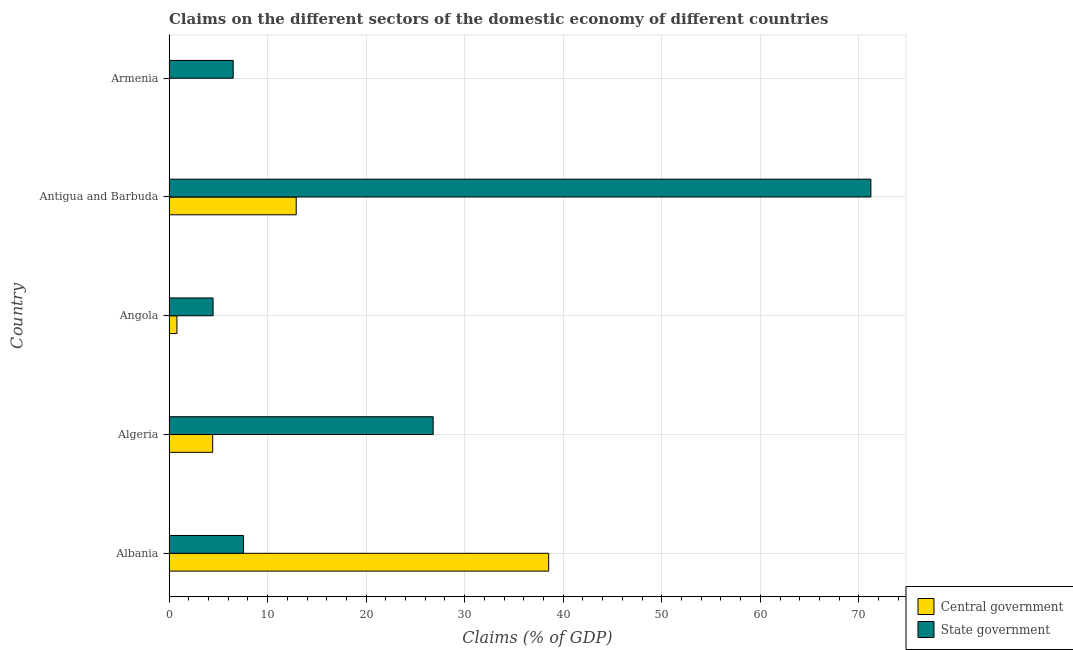Are the number of bars on each tick of the Y-axis equal?
Your response must be concise. No. What is the label of the 5th group of bars from the top?
Keep it short and to the point. Albania. What is the claims on state government in Angola?
Offer a terse response. 4.47. Across all countries, what is the maximum claims on central government?
Give a very brief answer. 38.52. In which country was the claims on state government maximum?
Your answer should be very brief. Antigua and Barbuda. What is the total claims on central government in the graph?
Offer a terse response. 56.66. What is the difference between the claims on state government in Angola and that in Armenia?
Make the answer very short. -2.04. What is the difference between the claims on central government in Antigua and Barbuda and the claims on state government in Algeria?
Your answer should be very brief. -13.9. What is the average claims on state government per country?
Give a very brief answer. 23.31. What is the difference between the claims on central government and claims on state government in Angola?
Keep it short and to the point. -3.67. In how many countries, is the claims on central government greater than 44 %?
Your answer should be very brief. 0. What is the ratio of the claims on central government in Angola to that in Antigua and Barbuda?
Provide a short and direct response. 0.06. Is the difference between the claims on central government in Albania and Antigua and Barbuda greater than the difference between the claims on state government in Albania and Antigua and Barbuda?
Provide a succinct answer. Yes. What is the difference between the highest and the second highest claims on state government?
Keep it short and to the point. 44.41. What is the difference between the highest and the lowest claims on central government?
Give a very brief answer. 38.52. In how many countries, is the claims on state government greater than the average claims on state government taken over all countries?
Make the answer very short. 2. Is the sum of the claims on state government in Albania and Algeria greater than the maximum claims on central government across all countries?
Make the answer very short. No. How many bars are there?
Your response must be concise. 9. What is the difference between two consecutive major ticks on the X-axis?
Your answer should be very brief. 10. Does the graph contain any zero values?
Your answer should be compact. Yes. Where does the legend appear in the graph?
Offer a terse response. Bottom right. How many legend labels are there?
Make the answer very short. 2. How are the legend labels stacked?
Your answer should be compact. Vertical. What is the title of the graph?
Your response must be concise. Claims on the different sectors of the domestic economy of different countries. What is the label or title of the X-axis?
Ensure brevity in your answer.  Claims (% of GDP). What is the label or title of the Y-axis?
Your answer should be very brief. Country. What is the Claims (% of GDP) in Central government in Albania?
Your answer should be compact. 38.52. What is the Claims (% of GDP) of State government in Albania?
Your answer should be very brief. 7.56. What is the Claims (% of GDP) in Central government in Algeria?
Make the answer very short. 4.43. What is the Claims (% of GDP) in State government in Algeria?
Your answer should be very brief. 26.8. What is the Claims (% of GDP) in Central government in Angola?
Your answer should be compact. 0.81. What is the Claims (% of GDP) in State government in Angola?
Your answer should be very brief. 4.47. What is the Claims (% of GDP) of Central government in Antigua and Barbuda?
Offer a terse response. 12.91. What is the Claims (% of GDP) of State government in Antigua and Barbuda?
Your response must be concise. 71.21. What is the Claims (% of GDP) in State government in Armenia?
Offer a very short reply. 6.51. Across all countries, what is the maximum Claims (% of GDP) in Central government?
Ensure brevity in your answer.  38.52. Across all countries, what is the maximum Claims (% of GDP) in State government?
Offer a very short reply. 71.21. Across all countries, what is the minimum Claims (% of GDP) in State government?
Provide a succinct answer. 4.47. What is the total Claims (% of GDP) of Central government in the graph?
Your answer should be compact. 56.66. What is the total Claims (% of GDP) in State government in the graph?
Provide a succinct answer. 116.56. What is the difference between the Claims (% of GDP) of Central government in Albania and that in Algeria?
Offer a terse response. 34.09. What is the difference between the Claims (% of GDP) of State government in Albania and that in Algeria?
Provide a short and direct response. -19.24. What is the difference between the Claims (% of GDP) in Central government in Albania and that in Angola?
Your answer should be compact. 37.71. What is the difference between the Claims (% of GDP) in State government in Albania and that in Angola?
Ensure brevity in your answer.  3.09. What is the difference between the Claims (% of GDP) in Central government in Albania and that in Antigua and Barbuda?
Provide a succinct answer. 25.61. What is the difference between the Claims (% of GDP) of State government in Albania and that in Antigua and Barbuda?
Your answer should be very brief. -63.65. What is the difference between the Claims (% of GDP) of State government in Albania and that in Armenia?
Make the answer very short. 1.05. What is the difference between the Claims (% of GDP) in Central government in Algeria and that in Angola?
Your answer should be very brief. 3.63. What is the difference between the Claims (% of GDP) of State government in Algeria and that in Angola?
Offer a very short reply. 22.33. What is the difference between the Claims (% of GDP) in Central government in Algeria and that in Antigua and Barbuda?
Ensure brevity in your answer.  -8.47. What is the difference between the Claims (% of GDP) of State government in Algeria and that in Antigua and Barbuda?
Offer a very short reply. -44.41. What is the difference between the Claims (% of GDP) in State government in Algeria and that in Armenia?
Provide a succinct answer. 20.29. What is the difference between the Claims (% of GDP) of Central government in Angola and that in Antigua and Barbuda?
Make the answer very short. -12.1. What is the difference between the Claims (% of GDP) in State government in Angola and that in Antigua and Barbuda?
Keep it short and to the point. -66.74. What is the difference between the Claims (% of GDP) of State government in Angola and that in Armenia?
Give a very brief answer. -2.04. What is the difference between the Claims (% of GDP) of State government in Antigua and Barbuda and that in Armenia?
Offer a very short reply. 64.7. What is the difference between the Claims (% of GDP) of Central government in Albania and the Claims (% of GDP) of State government in Algeria?
Your response must be concise. 11.72. What is the difference between the Claims (% of GDP) in Central government in Albania and the Claims (% of GDP) in State government in Angola?
Keep it short and to the point. 34.05. What is the difference between the Claims (% of GDP) in Central government in Albania and the Claims (% of GDP) in State government in Antigua and Barbuda?
Ensure brevity in your answer.  -32.69. What is the difference between the Claims (% of GDP) of Central government in Albania and the Claims (% of GDP) of State government in Armenia?
Keep it short and to the point. 32.01. What is the difference between the Claims (% of GDP) in Central government in Algeria and the Claims (% of GDP) in State government in Angola?
Your response must be concise. -0.04. What is the difference between the Claims (% of GDP) in Central government in Algeria and the Claims (% of GDP) in State government in Antigua and Barbuda?
Ensure brevity in your answer.  -66.78. What is the difference between the Claims (% of GDP) in Central government in Algeria and the Claims (% of GDP) in State government in Armenia?
Your response must be concise. -2.08. What is the difference between the Claims (% of GDP) of Central government in Angola and the Claims (% of GDP) of State government in Antigua and Barbuda?
Your answer should be compact. -70.4. What is the difference between the Claims (% of GDP) in Central government in Angola and the Claims (% of GDP) in State government in Armenia?
Your response must be concise. -5.71. What is the difference between the Claims (% of GDP) in Central government in Antigua and Barbuda and the Claims (% of GDP) in State government in Armenia?
Make the answer very short. 6.39. What is the average Claims (% of GDP) in Central government per country?
Offer a very short reply. 11.33. What is the average Claims (% of GDP) of State government per country?
Make the answer very short. 23.31. What is the difference between the Claims (% of GDP) of Central government and Claims (% of GDP) of State government in Albania?
Your answer should be compact. 30.96. What is the difference between the Claims (% of GDP) in Central government and Claims (% of GDP) in State government in Algeria?
Make the answer very short. -22.37. What is the difference between the Claims (% of GDP) of Central government and Claims (% of GDP) of State government in Angola?
Provide a succinct answer. -3.67. What is the difference between the Claims (% of GDP) in Central government and Claims (% of GDP) in State government in Antigua and Barbuda?
Keep it short and to the point. -58.3. What is the ratio of the Claims (% of GDP) in Central government in Albania to that in Algeria?
Your response must be concise. 8.69. What is the ratio of the Claims (% of GDP) of State government in Albania to that in Algeria?
Offer a terse response. 0.28. What is the ratio of the Claims (% of GDP) of Central government in Albania to that in Angola?
Provide a succinct answer. 47.75. What is the ratio of the Claims (% of GDP) in State government in Albania to that in Angola?
Offer a terse response. 1.69. What is the ratio of the Claims (% of GDP) in Central government in Albania to that in Antigua and Barbuda?
Give a very brief answer. 2.98. What is the ratio of the Claims (% of GDP) of State government in Albania to that in Antigua and Barbuda?
Keep it short and to the point. 0.11. What is the ratio of the Claims (% of GDP) in State government in Albania to that in Armenia?
Your response must be concise. 1.16. What is the ratio of the Claims (% of GDP) of Central government in Algeria to that in Angola?
Your answer should be very brief. 5.49. What is the ratio of the Claims (% of GDP) in State government in Algeria to that in Angola?
Your response must be concise. 5.99. What is the ratio of the Claims (% of GDP) of Central government in Algeria to that in Antigua and Barbuda?
Provide a succinct answer. 0.34. What is the ratio of the Claims (% of GDP) of State government in Algeria to that in Antigua and Barbuda?
Keep it short and to the point. 0.38. What is the ratio of the Claims (% of GDP) of State government in Algeria to that in Armenia?
Provide a succinct answer. 4.12. What is the ratio of the Claims (% of GDP) of Central government in Angola to that in Antigua and Barbuda?
Offer a very short reply. 0.06. What is the ratio of the Claims (% of GDP) in State government in Angola to that in Antigua and Barbuda?
Ensure brevity in your answer.  0.06. What is the ratio of the Claims (% of GDP) of State government in Angola to that in Armenia?
Offer a terse response. 0.69. What is the ratio of the Claims (% of GDP) of State government in Antigua and Barbuda to that in Armenia?
Your answer should be compact. 10.93. What is the difference between the highest and the second highest Claims (% of GDP) of Central government?
Offer a terse response. 25.61. What is the difference between the highest and the second highest Claims (% of GDP) of State government?
Make the answer very short. 44.41. What is the difference between the highest and the lowest Claims (% of GDP) in Central government?
Provide a short and direct response. 38.52. What is the difference between the highest and the lowest Claims (% of GDP) of State government?
Offer a very short reply. 66.74. 